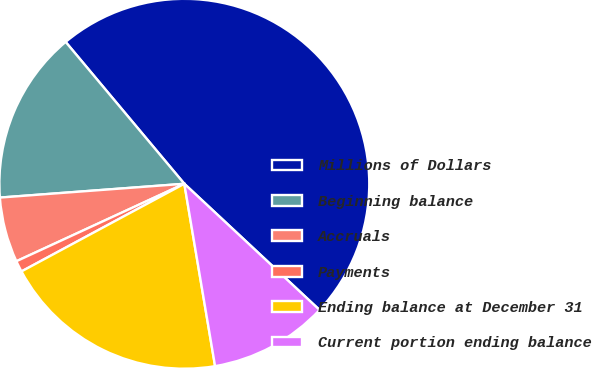Convert chart. <chart><loc_0><loc_0><loc_500><loc_500><pie_chart><fcel>Millions of Dollars<fcel>Beginning balance<fcel>Accruals<fcel>Payments<fcel>Ending balance at December 31<fcel>Current portion ending balance<nl><fcel>48.04%<fcel>15.1%<fcel>5.69%<fcel>0.98%<fcel>19.8%<fcel>10.39%<nl></chart> 